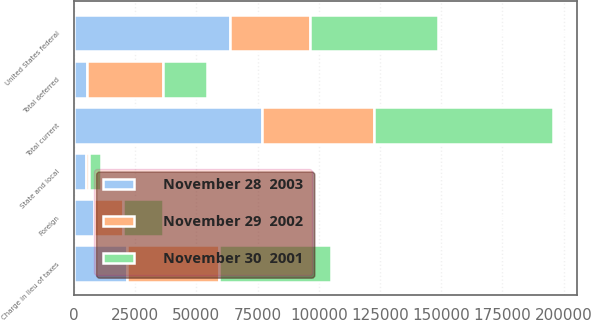Convert chart to OTSL. <chart><loc_0><loc_0><loc_500><loc_500><stacked_bar_chart><ecel><fcel>United States federal<fcel>Foreign<fcel>State and local<fcel>Total current<fcel>Total deferred<fcel>Charge in lieu of taxes<nl><fcel>November 29  2002<fcel>32751<fcel>11814<fcel>1090<fcel>45655<fcel>31057<fcel>37436<nl><fcel>November 28  2003<fcel>63547<fcel>8344<fcel>5055<fcel>76946<fcel>5486<fcel>21830<nl><fcel>November 30  2001<fcel>52355<fcel>16087<fcel>4753<fcel>73195<fcel>17600<fcel>45692<nl></chart> 